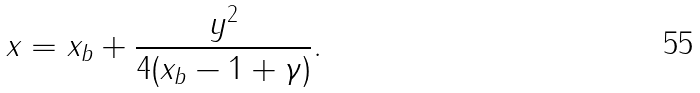Convert formula to latex. <formula><loc_0><loc_0><loc_500><loc_500>x = x _ { b } + \frac { y ^ { 2 } } { 4 ( x _ { b } - 1 + \gamma ) } .</formula> 